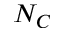<formula> <loc_0><loc_0><loc_500><loc_500>N _ { C }</formula> 